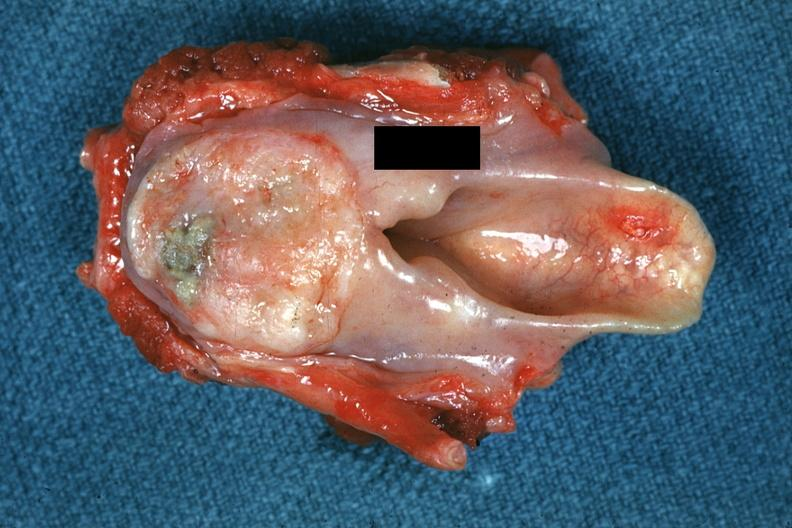s hypopharynx present?
Answer the question using a single word or phrase. Yes 